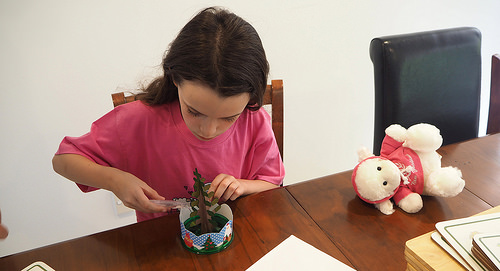<image>
Is the tree on the table? Yes. Looking at the image, I can see the tree is positioned on top of the table, with the table providing support. 